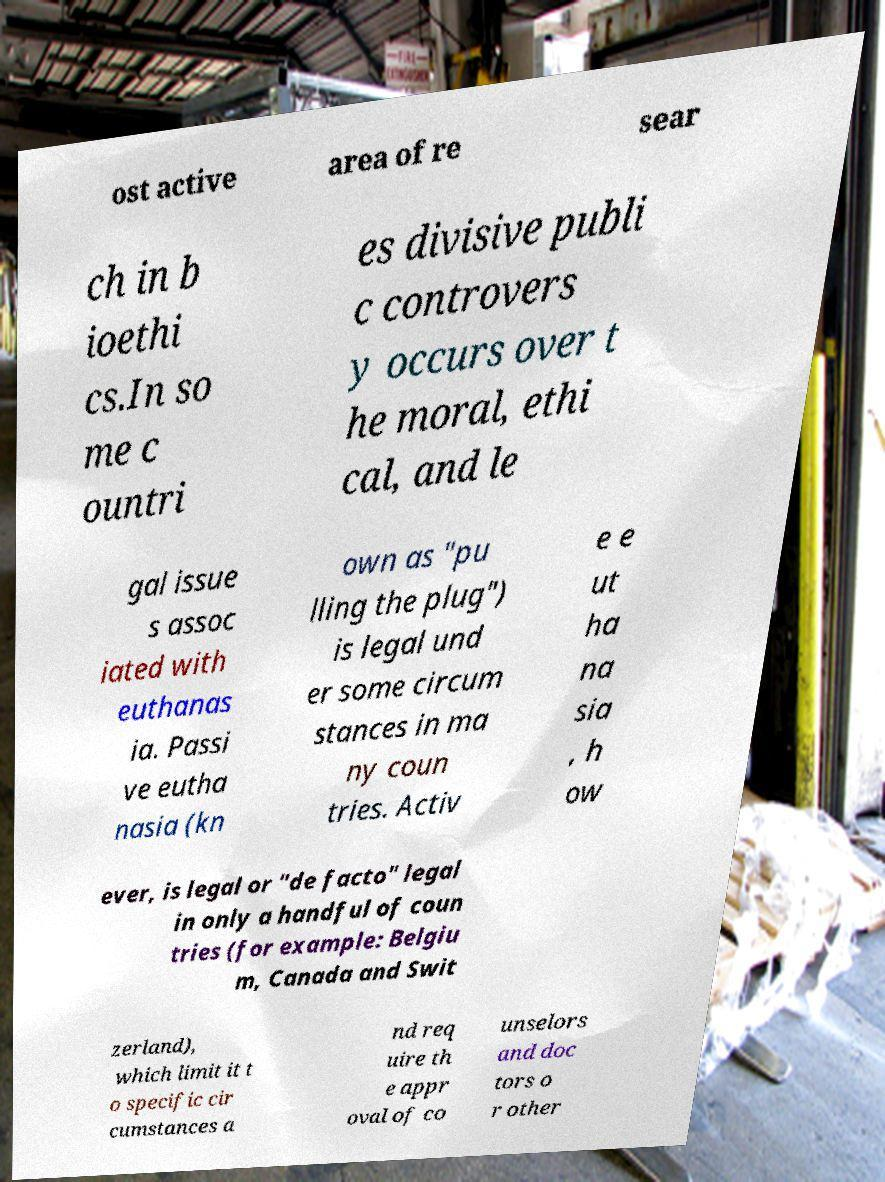Please identify and transcribe the text found in this image. ost active area of re sear ch in b ioethi cs.In so me c ountri es divisive publi c controvers y occurs over t he moral, ethi cal, and le gal issue s assoc iated with euthanas ia. Passi ve eutha nasia (kn own as "pu lling the plug") is legal und er some circum stances in ma ny coun tries. Activ e e ut ha na sia , h ow ever, is legal or "de facto" legal in only a handful of coun tries (for example: Belgiu m, Canada and Swit zerland), which limit it t o specific cir cumstances a nd req uire th e appr oval of co unselors and doc tors o r other 